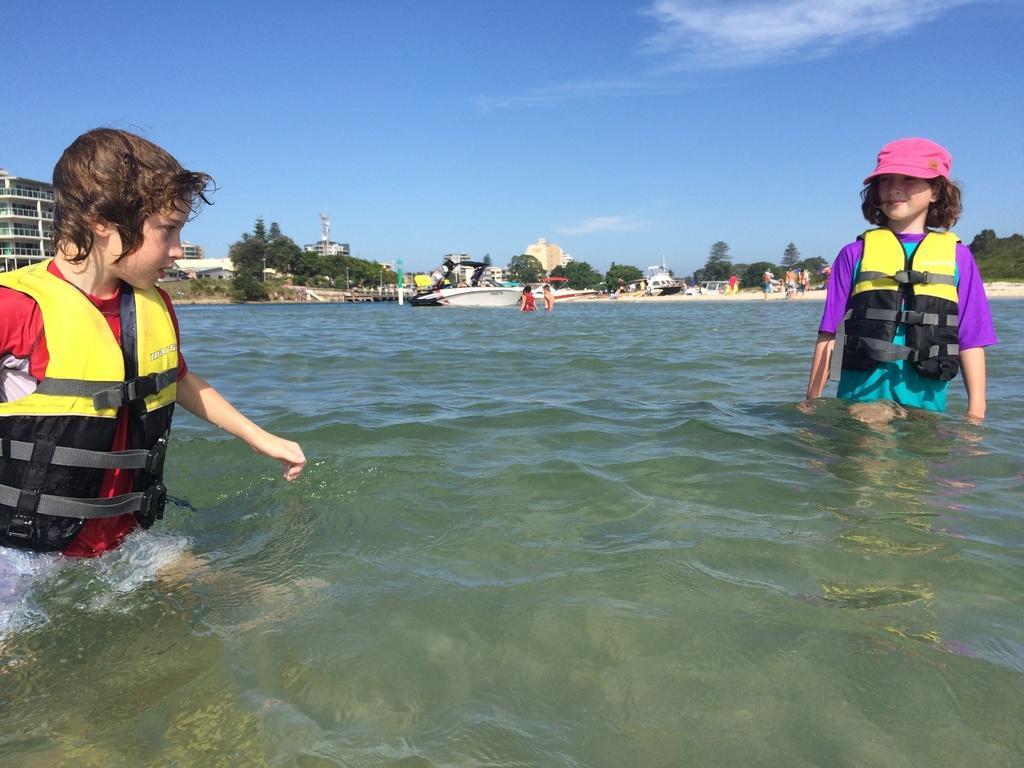How would you summarize this image in a sentence or two? This picture is clicked outside the city. Here, we see two children are standing in the water. In the background, we see trees, buildings and boats. There are people standing at the seashore. At the top of the picture, we see the sky. 